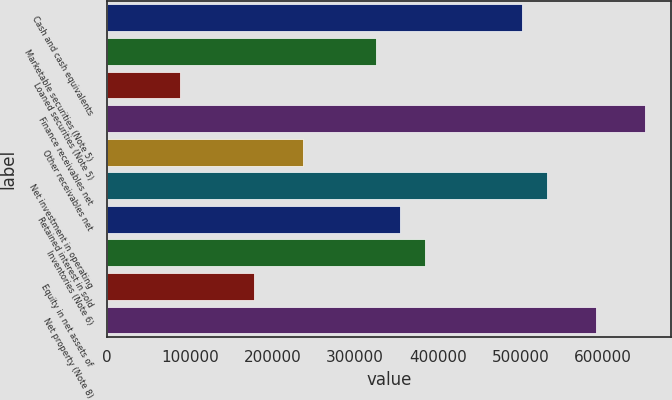<chart> <loc_0><loc_0><loc_500><loc_500><bar_chart><fcel>Cash and cash equivalents<fcel>Marketable securities (Note 5)<fcel>Loaned securities (Note 5)<fcel>Finance receivables net<fcel>Other receivables net<fcel>Net investment in operating<fcel>Retained interest in sold<fcel>Inventories (Note 6)<fcel>Equity in net assets of<fcel>Net property (Note 8)<nl><fcel>502360<fcel>325056<fcel>88652.5<fcel>650112<fcel>236405<fcel>531910<fcel>354607<fcel>384158<fcel>177304<fcel>591011<nl></chart> 